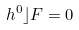Convert formula to latex. <formula><loc_0><loc_0><loc_500><loc_500>h ^ { 0 } \rfloor F = 0</formula> 